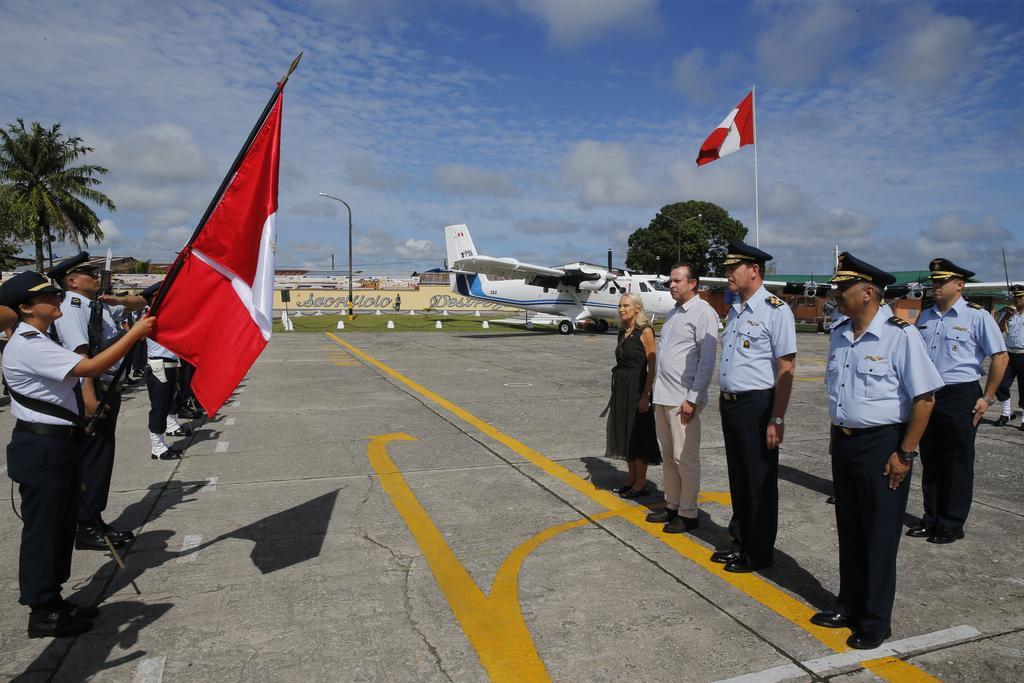Could you give a brief overview of what you see in this image? In the foreground of the picture there are soldiers, people. On the left there is a person holding flag. In the background towards left there are trees, buildings, street light, grass and wall. In the center of the picture there are aircraft, trees and a flag. Sky is sunny. 